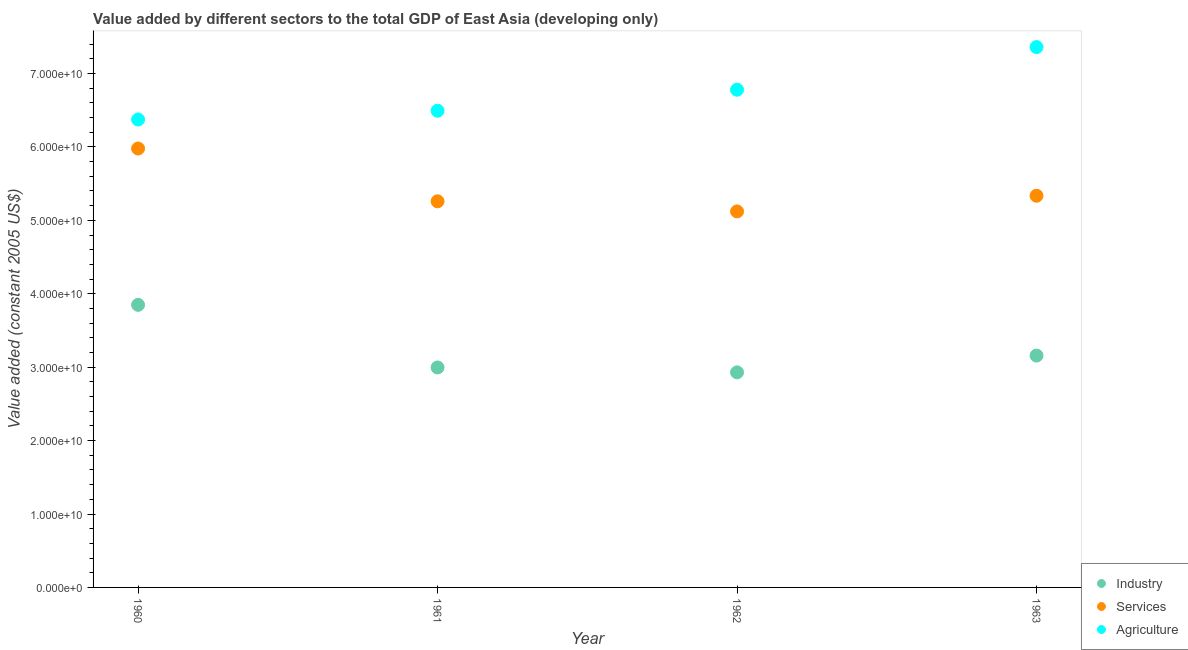How many different coloured dotlines are there?
Your answer should be very brief. 3. Is the number of dotlines equal to the number of legend labels?
Make the answer very short. Yes. What is the value added by agricultural sector in 1961?
Your answer should be very brief. 6.49e+1. Across all years, what is the maximum value added by services?
Make the answer very short. 5.98e+1. Across all years, what is the minimum value added by agricultural sector?
Provide a short and direct response. 6.37e+1. In which year was the value added by agricultural sector minimum?
Provide a short and direct response. 1960. What is the total value added by services in the graph?
Offer a very short reply. 2.17e+11. What is the difference between the value added by industrial sector in 1961 and that in 1962?
Ensure brevity in your answer.  6.65e+08. What is the difference between the value added by agricultural sector in 1963 and the value added by industrial sector in 1962?
Provide a succinct answer. 4.43e+1. What is the average value added by industrial sector per year?
Your answer should be very brief. 3.23e+1. In the year 1961, what is the difference between the value added by agricultural sector and value added by industrial sector?
Provide a succinct answer. 3.50e+1. What is the ratio of the value added by agricultural sector in 1961 to that in 1962?
Provide a short and direct response. 0.96. What is the difference between the highest and the second highest value added by industrial sector?
Offer a very short reply. 6.91e+09. What is the difference between the highest and the lowest value added by agricultural sector?
Ensure brevity in your answer.  9.86e+09. In how many years, is the value added by services greater than the average value added by services taken over all years?
Provide a short and direct response. 1. Is the sum of the value added by agricultural sector in 1960 and 1963 greater than the maximum value added by industrial sector across all years?
Keep it short and to the point. Yes. Is the value added by services strictly greater than the value added by industrial sector over the years?
Ensure brevity in your answer.  Yes. How many dotlines are there?
Make the answer very short. 3. How many years are there in the graph?
Provide a succinct answer. 4. What is the difference between two consecutive major ticks on the Y-axis?
Give a very brief answer. 1.00e+1. Are the values on the major ticks of Y-axis written in scientific E-notation?
Give a very brief answer. Yes. Does the graph contain grids?
Your answer should be very brief. No. How are the legend labels stacked?
Your response must be concise. Vertical. What is the title of the graph?
Keep it short and to the point. Value added by different sectors to the total GDP of East Asia (developing only). What is the label or title of the X-axis?
Make the answer very short. Year. What is the label or title of the Y-axis?
Give a very brief answer. Value added (constant 2005 US$). What is the Value added (constant 2005 US$) in Industry in 1960?
Your answer should be compact. 3.85e+1. What is the Value added (constant 2005 US$) in Services in 1960?
Offer a terse response. 5.98e+1. What is the Value added (constant 2005 US$) in Agriculture in 1960?
Your answer should be compact. 6.37e+1. What is the Value added (constant 2005 US$) in Industry in 1961?
Give a very brief answer. 3.00e+1. What is the Value added (constant 2005 US$) in Services in 1961?
Your answer should be compact. 5.26e+1. What is the Value added (constant 2005 US$) of Agriculture in 1961?
Offer a very short reply. 6.49e+1. What is the Value added (constant 2005 US$) in Industry in 1962?
Your answer should be compact. 2.93e+1. What is the Value added (constant 2005 US$) of Services in 1962?
Offer a very short reply. 5.12e+1. What is the Value added (constant 2005 US$) in Agriculture in 1962?
Offer a terse response. 6.78e+1. What is the Value added (constant 2005 US$) of Industry in 1963?
Offer a terse response. 3.16e+1. What is the Value added (constant 2005 US$) of Services in 1963?
Your response must be concise. 5.34e+1. What is the Value added (constant 2005 US$) in Agriculture in 1963?
Ensure brevity in your answer.  7.36e+1. Across all years, what is the maximum Value added (constant 2005 US$) in Industry?
Give a very brief answer. 3.85e+1. Across all years, what is the maximum Value added (constant 2005 US$) in Services?
Give a very brief answer. 5.98e+1. Across all years, what is the maximum Value added (constant 2005 US$) of Agriculture?
Your response must be concise. 7.36e+1. Across all years, what is the minimum Value added (constant 2005 US$) in Industry?
Your response must be concise. 2.93e+1. Across all years, what is the minimum Value added (constant 2005 US$) of Services?
Make the answer very short. 5.12e+1. Across all years, what is the minimum Value added (constant 2005 US$) of Agriculture?
Make the answer very short. 6.37e+1. What is the total Value added (constant 2005 US$) in Industry in the graph?
Your response must be concise. 1.29e+11. What is the total Value added (constant 2005 US$) of Services in the graph?
Offer a very short reply. 2.17e+11. What is the total Value added (constant 2005 US$) in Agriculture in the graph?
Ensure brevity in your answer.  2.70e+11. What is the difference between the Value added (constant 2005 US$) of Industry in 1960 and that in 1961?
Offer a very short reply. 8.53e+09. What is the difference between the Value added (constant 2005 US$) of Services in 1960 and that in 1961?
Keep it short and to the point. 7.19e+09. What is the difference between the Value added (constant 2005 US$) of Agriculture in 1960 and that in 1961?
Ensure brevity in your answer.  -1.20e+09. What is the difference between the Value added (constant 2005 US$) of Industry in 1960 and that in 1962?
Keep it short and to the point. 9.20e+09. What is the difference between the Value added (constant 2005 US$) of Services in 1960 and that in 1962?
Offer a terse response. 8.57e+09. What is the difference between the Value added (constant 2005 US$) in Agriculture in 1960 and that in 1962?
Provide a short and direct response. -4.06e+09. What is the difference between the Value added (constant 2005 US$) of Industry in 1960 and that in 1963?
Offer a terse response. 6.91e+09. What is the difference between the Value added (constant 2005 US$) of Services in 1960 and that in 1963?
Offer a very short reply. 6.43e+09. What is the difference between the Value added (constant 2005 US$) in Agriculture in 1960 and that in 1963?
Ensure brevity in your answer.  -9.86e+09. What is the difference between the Value added (constant 2005 US$) in Industry in 1961 and that in 1962?
Provide a short and direct response. 6.65e+08. What is the difference between the Value added (constant 2005 US$) of Services in 1961 and that in 1962?
Give a very brief answer. 1.38e+09. What is the difference between the Value added (constant 2005 US$) in Agriculture in 1961 and that in 1962?
Your response must be concise. -2.86e+09. What is the difference between the Value added (constant 2005 US$) in Industry in 1961 and that in 1963?
Give a very brief answer. -1.62e+09. What is the difference between the Value added (constant 2005 US$) of Services in 1961 and that in 1963?
Provide a succinct answer. -7.56e+08. What is the difference between the Value added (constant 2005 US$) in Agriculture in 1961 and that in 1963?
Provide a short and direct response. -8.67e+09. What is the difference between the Value added (constant 2005 US$) in Industry in 1962 and that in 1963?
Your response must be concise. -2.29e+09. What is the difference between the Value added (constant 2005 US$) of Services in 1962 and that in 1963?
Offer a terse response. -2.14e+09. What is the difference between the Value added (constant 2005 US$) in Agriculture in 1962 and that in 1963?
Make the answer very short. -5.81e+09. What is the difference between the Value added (constant 2005 US$) of Industry in 1960 and the Value added (constant 2005 US$) of Services in 1961?
Offer a very short reply. -1.41e+1. What is the difference between the Value added (constant 2005 US$) in Industry in 1960 and the Value added (constant 2005 US$) in Agriculture in 1961?
Keep it short and to the point. -2.64e+1. What is the difference between the Value added (constant 2005 US$) in Services in 1960 and the Value added (constant 2005 US$) in Agriculture in 1961?
Offer a very short reply. -5.15e+09. What is the difference between the Value added (constant 2005 US$) in Industry in 1960 and the Value added (constant 2005 US$) in Services in 1962?
Your response must be concise. -1.27e+1. What is the difference between the Value added (constant 2005 US$) of Industry in 1960 and the Value added (constant 2005 US$) of Agriculture in 1962?
Your answer should be very brief. -2.93e+1. What is the difference between the Value added (constant 2005 US$) in Services in 1960 and the Value added (constant 2005 US$) in Agriculture in 1962?
Your answer should be compact. -8.01e+09. What is the difference between the Value added (constant 2005 US$) of Industry in 1960 and the Value added (constant 2005 US$) of Services in 1963?
Provide a succinct answer. -1.49e+1. What is the difference between the Value added (constant 2005 US$) in Industry in 1960 and the Value added (constant 2005 US$) in Agriculture in 1963?
Provide a succinct answer. -3.51e+1. What is the difference between the Value added (constant 2005 US$) in Services in 1960 and the Value added (constant 2005 US$) in Agriculture in 1963?
Ensure brevity in your answer.  -1.38e+1. What is the difference between the Value added (constant 2005 US$) in Industry in 1961 and the Value added (constant 2005 US$) in Services in 1962?
Provide a succinct answer. -2.13e+1. What is the difference between the Value added (constant 2005 US$) of Industry in 1961 and the Value added (constant 2005 US$) of Agriculture in 1962?
Your answer should be compact. -3.78e+1. What is the difference between the Value added (constant 2005 US$) of Services in 1961 and the Value added (constant 2005 US$) of Agriculture in 1962?
Offer a very short reply. -1.52e+1. What is the difference between the Value added (constant 2005 US$) in Industry in 1961 and the Value added (constant 2005 US$) in Services in 1963?
Your answer should be compact. -2.34e+1. What is the difference between the Value added (constant 2005 US$) in Industry in 1961 and the Value added (constant 2005 US$) in Agriculture in 1963?
Give a very brief answer. -4.36e+1. What is the difference between the Value added (constant 2005 US$) in Services in 1961 and the Value added (constant 2005 US$) in Agriculture in 1963?
Your answer should be compact. -2.10e+1. What is the difference between the Value added (constant 2005 US$) of Industry in 1962 and the Value added (constant 2005 US$) of Services in 1963?
Your response must be concise. -2.41e+1. What is the difference between the Value added (constant 2005 US$) of Industry in 1962 and the Value added (constant 2005 US$) of Agriculture in 1963?
Offer a terse response. -4.43e+1. What is the difference between the Value added (constant 2005 US$) in Services in 1962 and the Value added (constant 2005 US$) in Agriculture in 1963?
Make the answer very short. -2.24e+1. What is the average Value added (constant 2005 US$) in Industry per year?
Provide a short and direct response. 3.23e+1. What is the average Value added (constant 2005 US$) in Services per year?
Provide a short and direct response. 5.42e+1. What is the average Value added (constant 2005 US$) of Agriculture per year?
Give a very brief answer. 6.75e+1. In the year 1960, what is the difference between the Value added (constant 2005 US$) in Industry and Value added (constant 2005 US$) in Services?
Give a very brief answer. -2.13e+1. In the year 1960, what is the difference between the Value added (constant 2005 US$) of Industry and Value added (constant 2005 US$) of Agriculture?
Ensure brevity in your answer.  -2.52e+1. In the year 1960, what is the difference between the Value added (constant 2005 US$) of Services and Value added (constant 2005 US$) of Agriculture?
Ensure brevity in your answer.  -3.95e+09. In the year 1961, what is the difference between the Value added (constant 2005 US$) of Industry and Value added (constant 2005 US$) of Services?
Make the answer very short. -2.26e+1. In the year 1961, what is the difference between the Value added (constant 2005 US$) in Industry and Value added (constant 2005 US$) in Agriculture?
Your response must be concise. -3.50e+1. In the year 1961, what is the difference between the Value added (constant 2005 US$) of Services and Value added (constant 2005 US$) of Agriculture?
Your response must be concise. -1.23e+1. In the year 1962, what is the difference between the Value added (constant 2005 US$) in Industry and Value added (constant 2005 US$) in Services?
Offer a terse response. -2.19e+1. In the year 1962, what is the difference between the Value added (constant 2005 US$) of Industry and Value added (constant 2005 US$) of Agriculture?
Your answer should be very brief. -3.85e+1. In the year 1962, what is the difference between the Value added (constant 2005 US$) in Services and Value added (constant 2005 US$) in Agriculture?
Give a very brief answer. -1.66e+1. In the year 1963, what is the difference between the Value added (constant 2005 US$) in Industry and Value added (constant 2005 US$) in Services?
Your response must be concise. -2.18e+1. In the year 1963, what is the difference between the Value added (constant 2005 US$) in Industry and Value added (constant 2005 US$) in Agriculture?
Provide a short and direct response. -4.20e+1. In the year 1963, what is the difference between the Value added (constant 2005 US$) in Services and Value added (constant 2005 US$) in Agriculture?
Give a very brief answer. -2.02e+1. What is the ratio of the Value added (constant 2005 US$) in Industry in 1960 to that in 1961?
Provide a succinct answer. 1.28. What is the ratio of the Value added (constant 2005 US$) in Services in 1960 to that in 1961?
Your answer should be compact. 1.14. What is the ratio of the Value added (constant 2005 US$) of Agriculture in 1960 to that in 1961?
Give a very brief answer. 0.98. What is the ratio of the Value added (constant 2005 US$) in Industry in 1960 to that in 1962?
Provide a succinct answer. 1.31. What is the ratio of the Value added (constant 2005 US$) in Services in 1960 to that in 1962?
Give a very brief answer. 1.17. What is the ratio of the Value added (constant 2005 US$) of Agriculture in 1960 to that in 1962?
Provide a succinct answer. 0.94. What is the ratio of the Value added (constant 2005 US$) in Industry in 1960 to that in 1963?
Provide a short and direct response. 1.22. What is the ratio of the Value added (constant 2005 US$) in Services in 1960 to that in 1963?
Provide a succinct answer. 1.12. What is the ratio of the Value added (constant 2005 US$) in Agriculture in 1960 to that in 1963?
Give a very brief answer. 0.87. What is the ratio of the Value added (constant 2005 US$) in Industry in 1961 to that in 1962?
Give a very brief answer. 1.02. What is the ratio of the Value added (constant 2005 US$) in Services in 1961 to that in 1962?
Keep it short and to the point. 1.03. What is the ratio of the Value added (constant 2005 US$) of Agriculture in 1961 to that in 1962?
Your response must be concise. 0.96. What is the ratio of the Value added (constant 2005 US$) in Industry in 1961 to that in 1963?
Offer a very short reply. 0.95. What is the ratio of the Value added (constant 2005 US$) in Services in 1961 to that in 1963?
Provide a succinct answer. 0.99. What is the ratio of the Value added (constant 2005 US$) of Agriculture in 1961 to that in 1963?
Your response must be concise. 0.88. What is the ratio of the Value added (constant 2005 US$) in Industry in 1962 to that in 1963?
Give a very brief answer. 0.93. What is the ratio of the Value added (constant 2005 US$) of Agriculture in 1962 to that in 1963?
Offer a very short reply. 0.92. What is the difference between the highest and the second highest Value added (constant 2005 US$) in Industry?
Provide a succinct answer. 6.91e+09. What is the difference between the highest and the second highest Value added (constant 2005 US$) of Services?
Provide a succinct answer. 6.43e+09. What is the difference between the highest and the second highest Value added (constant 2005 US$) in Agriculture?
Ensure brevity in your answer.  5.81e+09. What is the difference between the highest and the lowest Value added (constant 2005 US$) in Industry?
Ensure brevity in your answer.  9.20e+09. What is the difference between the highest and the lowest Value added (constant 2005 US$) in Services?
Your answer should be compact. 8.57e+09. What is the difference between the highest and the lowest Value added (constant 2005 US$) in Agriculture?
Your response must be concise. 9.86e+09. 